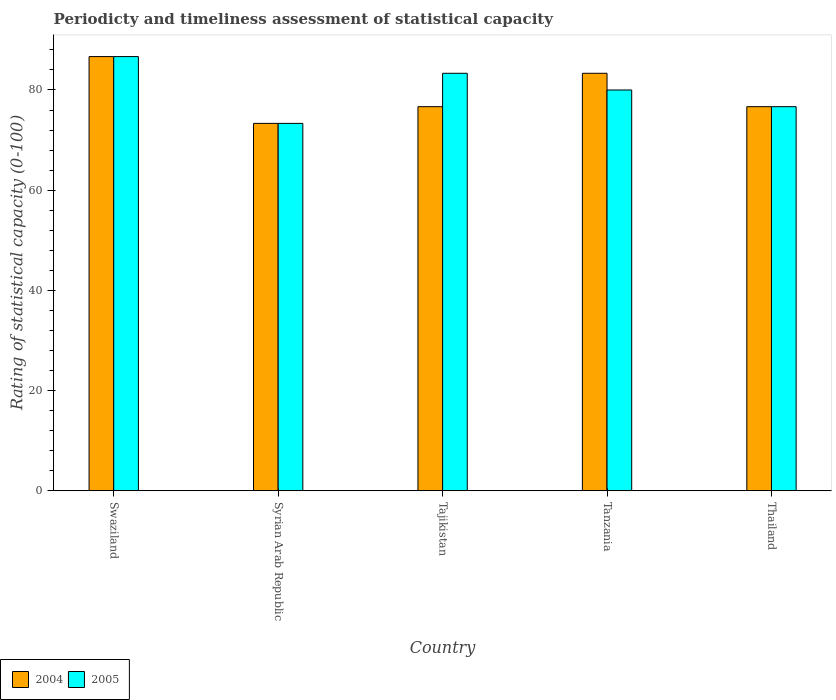How many different coloured bars are there?
Your answer should be compact. 2. How many groups of bars are there?
Keep it short and to the point. 5. Are the number of bars per tick equal to the number of legend labels?
Your answer should be compact. Yes. How many bars are there on the 1st tick from the left?
Provide a short and direct response. 2. How many bars are there on the 1st tick from the right?
Offer a terse response. 2. What is the label of the 3rd group of bars from the left?
Offer a very short reply. Tajikistan. In how many cases, is the number of bars for a given country not equal to the number of legend labels?
Give a very brief answer. 0. What is the rating of statistical capacity in 2005 in Thailand?
Your response must be concise. 76.67. Across all countries, what is the maximum rating of statistical capacity in 2004?
Your response must be concise. 86.67. Across all countries, what is the minimum rating of statistical capacity in 2005?
Offer a very short reply. 73.33. In which country was the rating of statistical capacity in 2005 maximum?
Your answer should be very brief. Swaziland. In which country was the rating of statistical capacity in 2004 minimum?
Give a very brief answer. Syrian Arab Republic. What is the total rating of statistical capacity in 2004 in the graph?
Provide a succinct answer. 396.67. What is the difference between the rating of statistical capacity in 2004 in Tajikistan and that in Tanzania?
Give a very brief answer. -6.67. What is the difference between the rating of statistical capacity in 2005 in Tajikistan and the rating of statistical capacity in 2004 in Tanzania?
Your answer should be very brief. 0. What is the difference between the rating of statistical capacity of/in 2004 and rating of statistical capacity of/in 2005 in Tanzania?
Offer a terse response. 3.33. In how many countries, is the rating of statistical capacity in 2005 greater than 76?
Provide a succinct answer. 4. What is the ratio of the rating of statistical capacity in 2004 in Tajikistan to that in Thailand?
Your answer should be very brief. 1. Is the rating of statistical capacity in 2004 in Syrian Arab Republic less than that in Tajikistan?
Ensure brevity in your answer.  Yes. Is the difference between the rating of statistical capacity in 2004 in Swaziland and Thailand greater than the difference between the rating of statistical capacity in 2005 in Swaziland and Thailand?
Offer a very short reply. No. What is the difference between the highest and the second highest rating of statistical capacity in 2004?
Make the answer very short. 6.67. What is the difference between the highest and the lowest rating of statistical capacity in 2004?
Your response must be concise. 13.33. In how many countries, is the rating of statistical capacity in 2005 greater than the average rating of statistical capacity in 2005 taken over all countries?
Provide a short and direct response. 2. What does the 1st bar from the left in Tanzania represents?
Keep it short and to the point. 2004. How many bars are there?
Your answer should be very brief. 10. Are all the bars in the graph horizontal?
Ensure brevity in your answer.  No. How many countries are there in the graph?
Ensure brevity in your answer.  5. What is the difference between two consecutive major ticks on the Y-axis?
Offer a very short reply. 20. Are the values on the major ticks of Y-axis written in scientific E-notation?
Your answer should be compact. No. Does the graph contain any zero values?
Provide a succinct answer. No. Does the graph contain grids?
Give a very brief answer. No. Where does the legend appear in the graph?
Make the answer very short. Bottom left. How are the legend labels stacked?
Offer a very short reply. Horizontal. What is the title of the graph?
Provide a succinct answer. Periodicty and timeliness assessment of statistical capacity. What is the label or title of the Y-axis?
Your answer should be very brief. Rating of statistical capacity (0-100). What is the Rating of statistical capacity (0-100) of 2004 in Swaziland?
Give a very brief answer. 86.67. What is the Rating of statistical capacity (0-100) of 2005 in Swaziland?
Ensure brevity in your answer.  86.67. What is the Rating of statistical capacity (0-100) in 2004 in Syrian Arab Republic?
Give a very brief answer. 73.33. What is the Rating of statistical capacity (0-100) in 2005 in Syrian Arab Republic?
Provide a short and direct response. 73.33. What is the Rating of statistical capacity (0-100) of 2004 in Tajikistan?
Offer a very short reply. 76.67. What is the Rating of statistical capacity (0-100) of 2005 in Tajikistan?
Offer a terse response. 83.33. What is the Rating of statistical capacity (0-100) in 2004 in Tanzania?
Make the answer very short. 83.33. What is the Rating of statistical capacity (0-100) of 2005 in Tanzania?
Make the answer very short. 80. What is the Rating of statistical capacity (0-100) of 2004 in Thailand?
Your response must be concise. 76.67. What is the Rating of statistical capacity (0-100) of 2005 in Thailand?
Provide a succinct answer. 76.67. Across all countries, what is the maximum Rating of statistical capacity (0-100) in 2004?
Provide a succinct answer. 86.67. Across all countries, what is the maximum Rating of statistical capacity (0-100) of 2005?
Your answer should be compact. 86.67. Across all countries, what is the minimum Rating of statistical capacity (0-100) of 2004?
Your answer should be compact. 73.33. Across all countries, what is the minimum Rating of statistical capacity (0-100) of 2005?
Ensure brevity in your answer.  73.33. What is the total Rating of statistical capacity (0-100) in 2004 in the graph?
Ensure brevity in your answer.  396.67. What is the total Rating of statistical capacity (0-100) of 2005 in the graph?
Your answer should be very brief. 400. What is the difference between the Rating of statistical capacity (0-100) of 2004 in Swaziland and that in Syrian Arab Republic?
Your response must be concise. 13.33. What is the difference between the Rating of statistical capacity (0-100) of 2005 in Swaziland and that in Syrian Arab Republic?
Offer a terse response. 13.33. What is the difference between the Rating of statistical capacity (0-100) in 2004 in Swaziland and that in Tanzania?
Offer a very short reply. 3.33. What is the difference between the Rating of statistical capacity (0-100) in 2005 in Swaziland and that in Tanzania?
Give a very brief answer. 6.67. What is the difference between the Rating of statistical capacity (0-100) of 2005 in Swaziland and that in Thailand?
Give a very brief answer. 10. What is the difference between the Rating of statistical capacity (0-100) of 2004 in Syrian Arab Republic and that in Tajikistan?
Your answer should be compact. -3.33. What is the difference between the Rating of statistical capacity (0-100) in 2005 in Syrian Arab Republic and that in Tanzania?
Give a very brief answer. -6.67. What is the difference between the Rating of statistical capacity (0-100) in 2004 in Syrian Arab Republic and that in Thailand?
Ensure brevity in your answer.  -3.33. What is the difference between the Rating of statistical capacity (0-100) of 2004 in Tajikistan and that in Tanzania?
Keep it short and to the point. -6.67. What is the difference between the Rating of statistical capacity (0-100) in 2005 in Tajikistan and that in Tanzania?
Your answer should be very brief. 3.33. What is the difference between the Rating of statistical capacity (0-100) in 2004 in Tajikistan and that in Thailand?
Your response must be concise. 0. What is the difference between the Rating of statistical capacity (0-100) in 2004 in Tanzania and that in Thailand?
Ensure brevity in your answer.  6.67. What is the difference between the Rating of statistical capacity (0-100) of 2004 in Swaziland and the Rating of statistical capacity (0-100) of 2005 in Syrian Arab Republic?
Give a very brief answer. 13.33. What is the difference between the Rating of statistical capacity (0-100) of 2004 in Swaziland and the Rating of statistical capacity (0-100) of 2005 in Tajikistan?
Provide a succinct answer. 3.33. What is the difference between the Rating of statistical capacity (0-100) in 2004 in Swaziland and the Rating of statistical capacity (0-100) in 2005 in Thailand?
Offer a very short reply. 10. What is the difference between the Rating of statistical capacity (0-100) of 2004 in Syrian Arab Republic and the Rating of statistical capacity (0-100) of 2005 in Tajikistan?
Your response must be concise. -10. What is the difference between the Rating of statistical capacity (0-100) of 2004 in Syrian Arab Republic and the Rating of statistical capacity (0-100) of 2005 in Tanzania?
Your answer should be compact. -6.67. What is the difference between the Rating of statistical capacity (0-100) in 2004 in Syrian Arab Republic and the Rating of statistical capacity (0-100) in 2005 in Thailand?
Ensure brevity in your answer.  -3.33. What is the difference between the Rating of statistical capacity (0-100) of 2004 in Tajikistan and the Rating of statistical capacity (0-100) of 2005 in Tanzania?
Make the answer very short. -3.33. What is the difference between the Rating of statistical capacity (0-100) in 2004 in Tajikistan and the Rating of statistical capacity (0-100) in 2005 in Thailand?
Your response must be concise. 0. What is the average Rating of statistical capacity (0-100) of 2004 per country?
Keep it short and to the point. 79.33. What is the average Rating of statistical capacity (0-100) in 2005 per country?
Ensure brevity in your answer.  80. What is the difference between the Rating of statistical capacity (0-100) in 2004 and Rating of statistical capacity (0-100) in 2005 in Swaziland?
Your response must be concise. 0. What is the difference between the Rating of statistical capacity (0-100) of 2004 and Rating of statistical capacity (0-100) of 2005 in Syrian Arab Republic?
Your response must be concise. 0. What is the difference between the Rating of statistical capacity (0-100) of 2004 and Rating of statistical capacity (0-100) of 2005 in Tajikistan?
Offer a very short reply. -6.67. What is the difference between the Rating of statistical capacity (0-100) in 2004 and Rating of statistical capacity (0-100) in 2005 in Thailand?
Provide a short and direct response. 0. What is the ratio of the Rating of statistical capacity (0-100) of 2004 in Swaziland to that in Syrian Arab Republic?
Make the answer very short. 1.18. What is the ratio of the Rating of statistical capacity (0-100) of 2005 in Swaziland to that in Syrian Arab Republic?
Your answer should be compact. 1.18. What is the ratio of the Rating of statistical capacity (0-100) in 2004 in Swaziland to that in Tajikistan?
Your answer should be very brief. 1.13. What is the ratio of the Rating of statistical capacity (0-100) in 2005 in Swaziland to that in Tajikistan?
Your answer should be compact. 1.04. What is the ratio of the Rating of statistical capacity (0-100) in 2004 in Swaziland to that in Thailand?
Make the answer very short. 1.13. What is the ratio of the Rating of statistical capacity (0-100) of 2005 in Swaziland to that in Thailand?
Your answer should be compact. 1.13. What is the ratio of the Rating of statistical capacity (0-100) in 2004 in Syrian Arab Republic to that in Tajikistan?
Your response must be concise. 0.96. What is the ratio of the Rating of statistical capacity (0-100) in 2005 in Syrian Arab Republic to that in Tajikistan?
Your answer should be very brief. 0.88. What is the ratio of the Rating of statistical capacity (0-100) of 2004 in Syrian Arab Republic to that in Tanzania?
Keep it short and to the point. 0.88. What is the ratio of the Rating of statistical capacity (0-100) in 2004 in Syrian Arab Republic to that in Thailand?
Offer a very short reply. 0.96. What is the ratio of the Rating of statistical capacity (0-100) of 2005 in Syrian Arab Republic to that in Thailand?
Your answer should be very brief. 0.96. What is the ratio of the Rating of statistical capacity (0-100) in 2005 in Tajikistan to that in Tanzania?
Provide a succinct answer. 1.04. What is the ratio of the Rating of statistical capacity (0-100) in 2004 in Tajikistan to that in Thailand?
Ensure brevity in your answer.  1. What is the ratio of the Rating of statistical capacity (0-100) of 2005 in Tajikistan to that in Thailand?
Ensure brevity in your answer.  1.09. What is the ratio of the Rating of statistical capacity (0-100) of 2004 in Tanzania to that in Thailand?
Ensure brevity in your answer.  1.09. What is the ratio of the Rating of statistical capacity (0-100) in 2005 in Tanzania to that in Thailand?
Offer a terse response. 1.04. What is the difference between the highest and the second highest Rating of statistical capacity (0-100) in 2004?
Your answer should be compact. 3.33. What is the difference between the highest and the second highest Rating of statistical capacity (0-100) of 2005?
Ensure brevity in your answer.  3.33. What is the difference between the highest and the lowest Rating of statistical capacity (0-100) of 2004?
Keep it short and to the point. 13.33. What is the difference between the highest and the lowest Rating of statistical capacity (0-100) in 2005?
Your answer should be very brief. 13.33. 